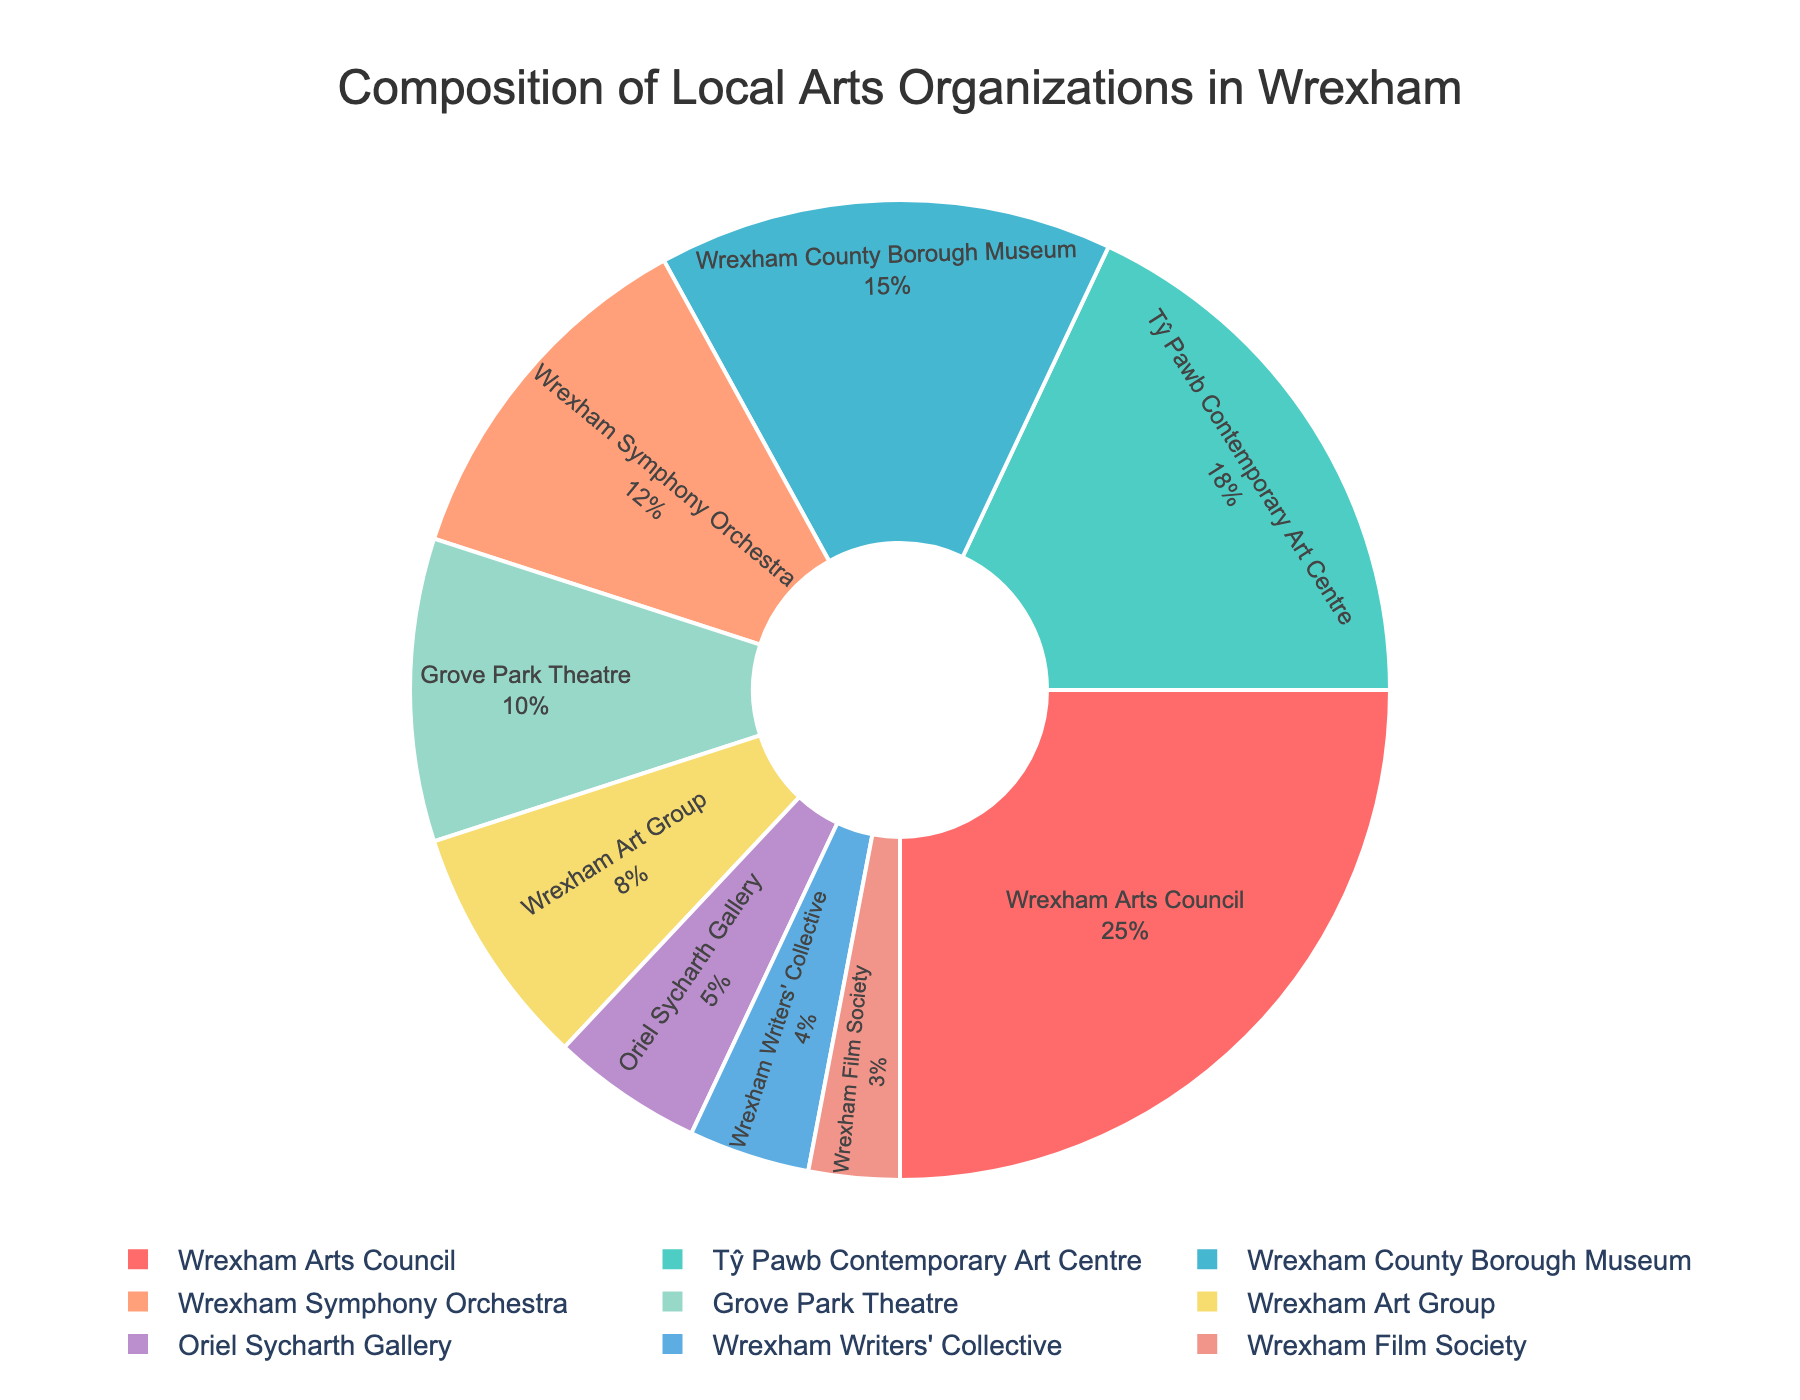What percentage of local arts organizations focus on visual arts (Tŷ Pawb Contemporary Art Centre, Wrexham Art Group, and Oriel Sycharth Gallery)? The percentages for visual arts organizations are 18% (Tŷ Pawb Contemporary Art Centre), 8% (Wrexham Art Group), and 5% (Oriel Sycharth Gallery). Summing them up: 18 + 8 + 5 = 31.
Answer: 31% Which organization has a greater percentage, Wrexham Symphony Orchestra or Grove Park Theatre? The percentages for Wrexham Symphony Orchestra and Grove Park Theatre are 12% and 10% respectively. Since 12% > 10%, Wrexham Symphony Orchestra has a greater percentage.
Answer: Wrexham Symphony Orchestra What is the total percentage of the three smallest organizations? The percentages of the three smallest organizations are 5% (Oriel Sycharth Gallery), 4% (Wrexham Writers' Collective), and 3% (Wrexham Film Society). Summing them: 5 + 4 + 3 = 12.
Answer: 12% Which organization occupies the largest slice of the pie chart and what percentage does it represent? The Wrexham Arts Council occupies the largest slice of the pie chart with 25%.
Answer: Wrexham Arts Council, 25% How much larger in percentage is the Wrexham Arts Council compared to Wrexham County Borough Museum? The percentage for Wrexham Arts Council is 25% and for Wrexham County Borough Museum is 15%. The difference is: 25 - 15 = 10.
Answer: 10% Which color represents the Tŷ Pawb Contemporary Art Centre on the pie chart? The Tŷ Pawb Contemporary Art Centre is represented by the green color on the pie chart.
Answer: Green What is the combined percentage of Wrexham Arts Council, Tŷ Pawb Contemporary Art Centre, and Wrexham County Borough Museum? The percentages are 25% (Wrexham Arts Council), 18% (Tŷ Pawb Contemporary Art Centre), and 15% (Wrexham County Borough Museum). Combining them: 25 + 18 + 15 = 58.
Answer: 58% Is Wrexham Film Society's percentage larger or smaller than Oriel Sycharth Gallery's percentage? Wrexham Film Society has 3% and Oriel Sycharth Gallery has 5%. Since 3% < 5%, Wrexham Film Society's percentage is smaller.
Answer: Smaller What is the median percentage value among all the organizations? Listing the percentages in ascending order: 3, 4, 5, 8, 10, 12, 15, 18, 25. The median value is the middle one in this ordered list, which is 10.
Answer: 10 What percentage of the organizations has a greater percentage than Wrexham Art Group? Organizations with greater percentages than Wrexham Art Group (8%) are Wrexham Arts Council (25%), Tŷ Pawb Contemporary Art Centre (18%), Wrexham County Borough Museum (15%), Wrexham Symphony Orchestra (12%), and Grove Park Theatre (10%). There are 5 such organizations.
Answer: 5 organizations 